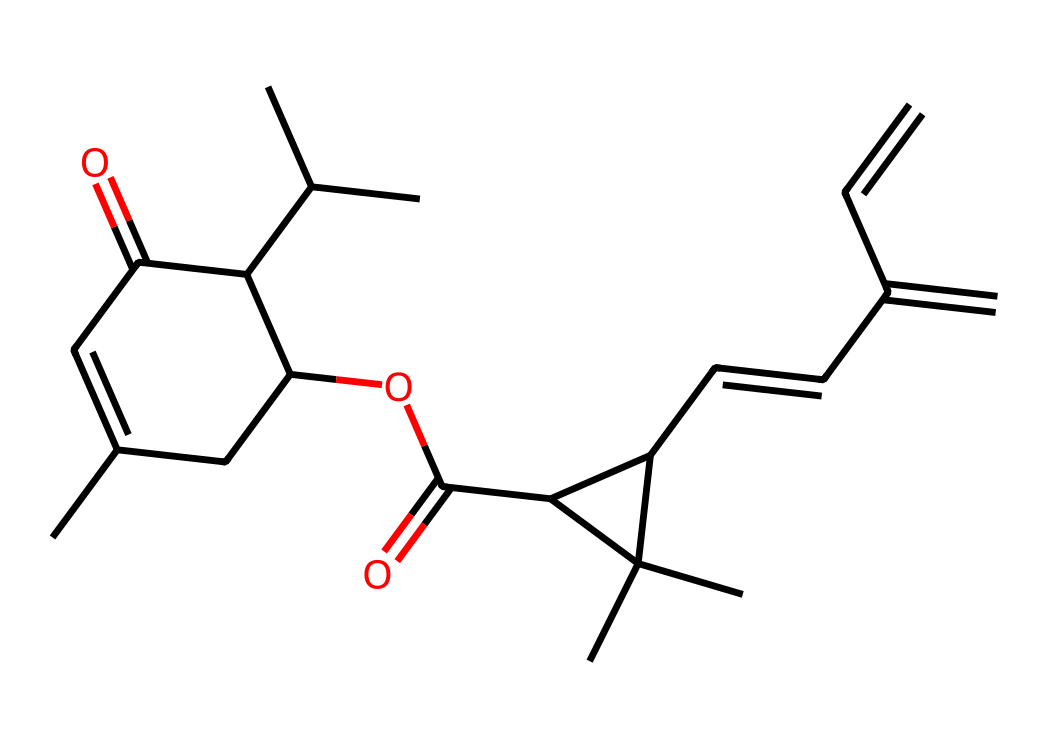What is the molecular formula of this chemical? To find the molecular formula, we need to count the number of each type of atom present in the SMILES representation. From the structure, we identify the carbon (C), hydrogen (H), and oxygen (O) atoms. By counting, we find 27 carbon atoms, 36 hydrogen atoms, and 4 oxygen atoms. This gives us the molecular formula C27H36O4.
Answer: C27H36O4 How many rings are present in the structure? By analyzing the SMILES, we need to identify the cyclic parts of the structure. The presence of numbers (like 1 and 2) indicates the locations of ring closures in the structure. There are two sets of numbered rings in the SMILES, which means there are 2 rings in this compound.
Answer: 2 What type of functional groups can be identified in this biopesticide? We can identify several functional groups by examining the structure. The presence of the carbonyl group (C=O) indicates a ketone and an ester group, as well as an ether due to the -O- linkages. Hence, the major functional groups include esters and ketones.
Answer: esters and ketones Which part of this biopesticide indicates its potential as a natural pesticide? The presence of multiple cyclic structures along with the functional groups, particularly the ester and ketone groups, suggests that this compound might interact with biological systems effectively, indicating its potential as a natural pesticide.
Answer: cyclic structures and functional groups How many chiral centers does this molecule have? To determine stereogenic or chiral centers, examine each carbon atom bonded to four different substituents. From the structure and the SMILES, we find that there are 5 chiral centers present in this molecule.
Answer: 5 